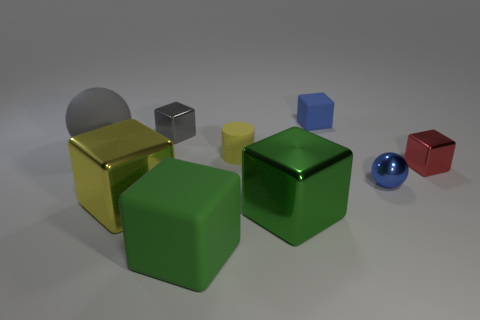Subtract all gray blocks. How many blocks are left? 5 Subtract all large yellow metallic cubes. How many cubes are left? 5 Subtract all brown cubes. Subtract all yellow cylinders. How many cubes are left? 6 Add 1 green matte blocks. How many objects exist? 10 Subtract all cubes. How many objects are left? 3 Subtract 0 brown blocks. How many objects are left? 9 Subtract all gray shiny things. Subtract all tiny shiny blocks. How many objects are left? 6 Add 2 yellow things. How many yellow things are left? 4 Add 2 red cubes. How many red cubes exist? 3 